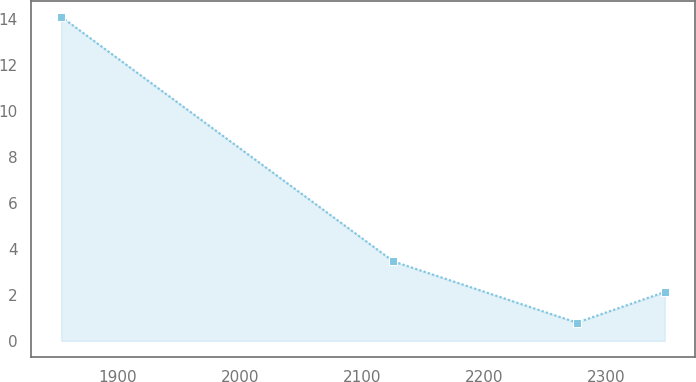<chart> <loc_0><loc_0><loc_500><loc_500><line_chart><ecel><fcel>Unnamed: 1<nl><fcel>1853.42<fcel>14.08<nl><fcel>2125.89<fcel>3.45<nl><fcel>2276.26<fcel>0.79<nl><fcel>2348.35<fcel>2.12<nl></chart> 